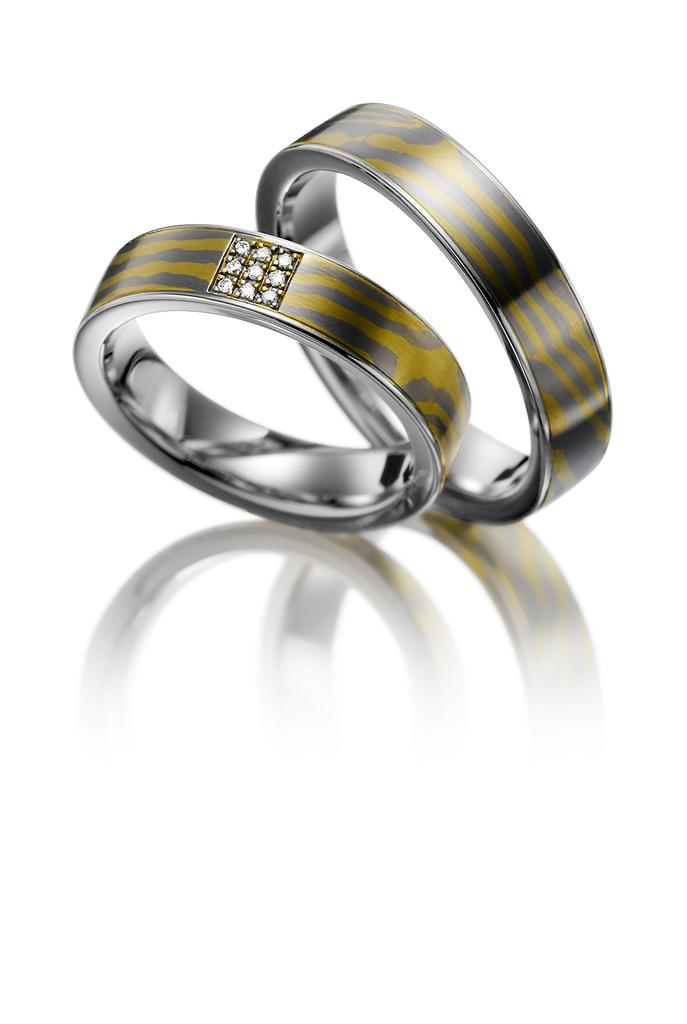What is the main subject of the image? The main subject of the image consists of rings. What material do the rings appear to be made of? The rings appear to be made of platinum. What can be found in the center of the rings? There are stones in the middle of the rings. How does the tongue interact with the rings in the image? There is no tongue present in the image, as it features rings made of platinum with stones in the center. 